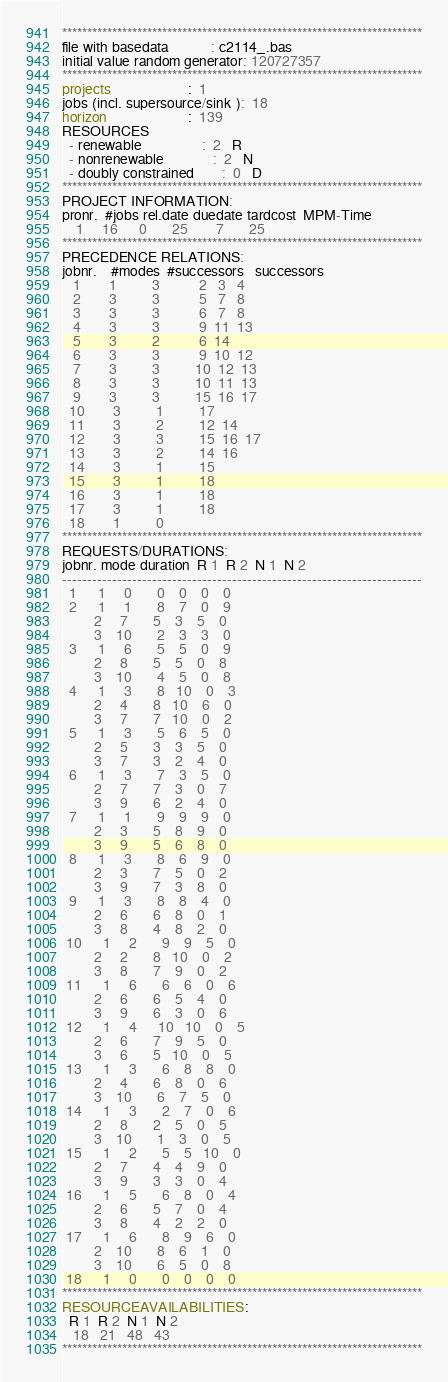<code> <loc_0><loc_0><loc_500><loc_500><_ObjectiveC_>************************************************************************
file with basedata            : c2114_.bas
initial value random generator: 120727357
************************************************************************
projects                      :  1
jobs (incl. supersource/sink ):  18
horizon                       :  139
RESOURCES
  - renewable                 :  2   R
  - nonrenewable              :  2   N
  - doubly constrained        :  0   D
************************************************************************
PROJECT INFORMATION:
pronr.  #jobs rel.date duedate tardcost  MPM-Time
    1     16      0       25        7       25
************************************************************************
PRECEDENCE RELATIONS:
jobnr.    #modes  #successors   successors
   1        1          3           2   3   4
   2        3          3           5   7   8
   3        3          3           6   7   8
   4        3          3           9  11  13
   5        3          2           6  14
   6        3          3           9  10  12
   7        3          3          10  12  13
   8        3          3          10  11  13
   9        3          3          15  16  17
  10        3          1          17
  11        3          2          12  14
  12        3          3          15  16  17
  13        3          2          14  16
  14        3          1          15
  15        3          1          18
  16        3          1          18
  17        3          1          18
  18        1          0        
************************************************************************
REQUESTS/DURATIONS:
jobnr. mode duration  R 1  R 2  N 1  N 2
------------------------------------------------------------------------
  1      1     0       0    0    0    0
  2      1     1       8    7    0    9
         2     7       5    3    5    0
         3    10       2    3    3    0
  3      1     6       5    5    0    9
         2     8       5    5    0    8
         3    10       4    5    0    8
  4      1     3       8   10    0    3
         2     4       8   10    6    0
         3     7       7   10    0    2
  5      1     3       5    6    5    0
         2     5       3    3    5    0
         3     7       3    2    4    0
  6      1     3       7    3    5    0
         2     7       7    3    0    7
         3     9       6    2    4    0
  7      1     1       9    9    9    0
         2     3       5    8    9    0
         3     9       5    6    8    0
  8      1     3       8    6    9    0
         2     3       7    5    0    2
         3     9       7    3    8    0
  9      1     3       8    8    4    0
         2     6       6    8    0    1
         3     8       4    8    2    0
 10      1     2       9    9    5    0
         2     2       8   10    0    2
         3     8       7    9    0    2
 11      1     6       6    6    0    6
         2     6       6    5    4    0
         3     9       6    3    0    6
 12      1     4      10   10    0    5
         2     6       7    9    5    0
         3     6       5   10    0    5
 13      1     3       6    8    8    0
         2     4       6    8    0    6
         3    10       6    7    5    0
 14      1     3       2    7    0    6
         2     8       2    5    0    5
         3    10       1    3    0    5
 15      1     2       5    5   10    0
         2     7       4    4    9    0
         3     9       3    3    0    4
 16      1     5       6    8    0    4
         2     6       5    7    0    4
         3     8       4    2    2    0
 17      1     6       8    9    6    0
         2    10       8    6    1    0
         3    10       6    5    0    8
 18      1     0       0    0    0    0
************************************************************************
RESOURCEAVAILABILITIES:
  R 1  R 2  N 1  N 2
   18   21   48   43
************************************************************************
</code> 